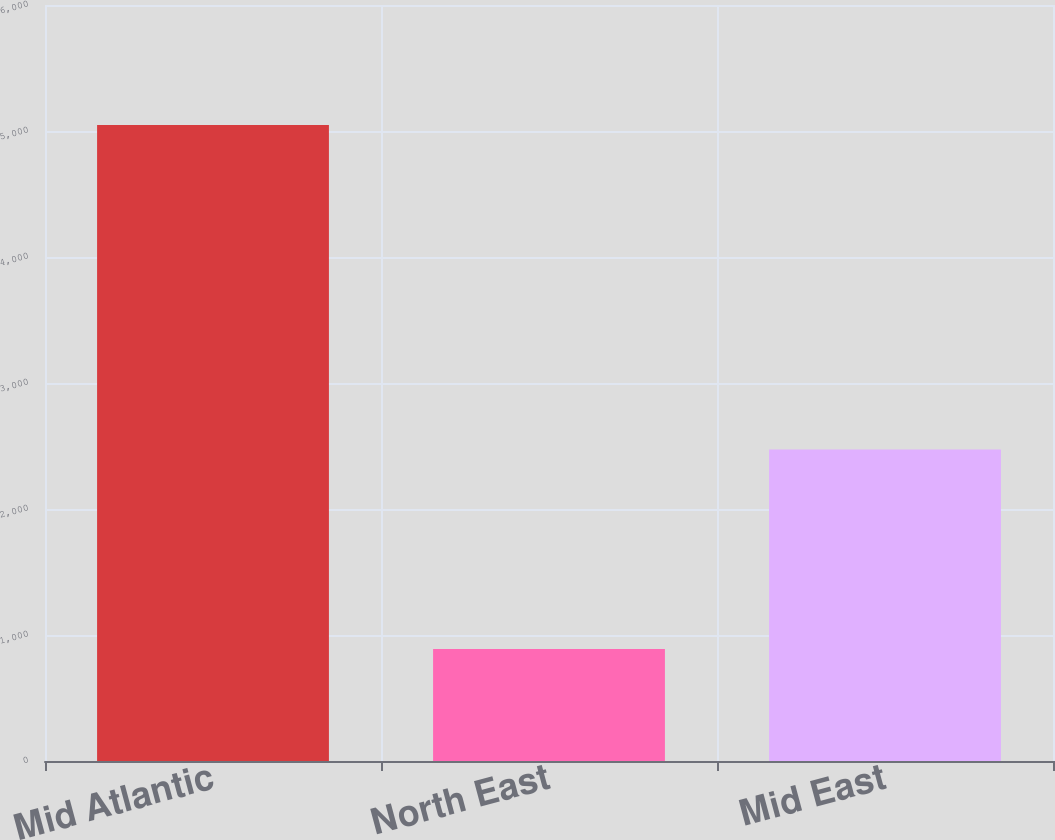<chart> <loc_0><loc_0><loc_500><loc_500><bar_chart><fcel>Mid Atlantic<fcel>North East<fcel>Mid East<nl><fcel>5047<fcel>889<fcel>2472<nl></chart> 